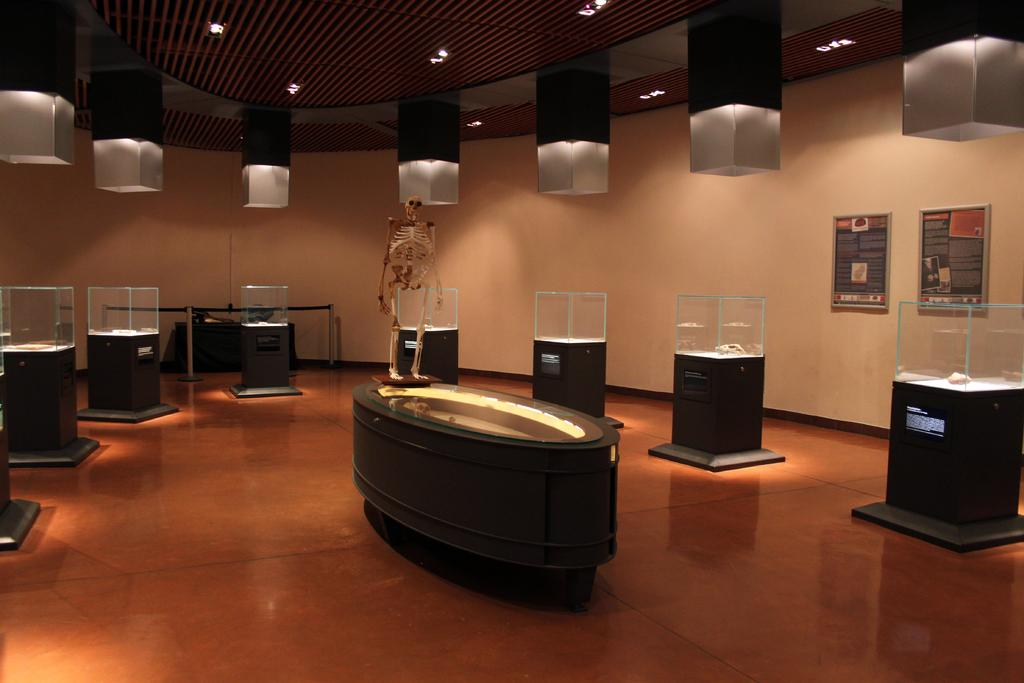What objects are on the wooden surface in the image? There are glass boxes on a wooden surface in the image. What can be seen in the background of the image? There are two posts attached to the wall in the background. What color is the wall in the image? The wall is in cream color. What can provide illumination in the image? There are lights visible in the image. What type of fruit can be seen growing in the field in the image? There is no field or fruit present in the image; it features glass boxes on a wooden surface with a cream-colored wall and lights in the background. 